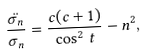Convert formula to latex. <formula><loc_0><loc_0><loc_500><loc_500>\frac { \ddot { \sigma _ { n } } } { \sigma _ { n } } = \frac { c ( c + 1 ) } { \cos ^ { 2 } \, t } - n ^ { 2 } ,</formula> 